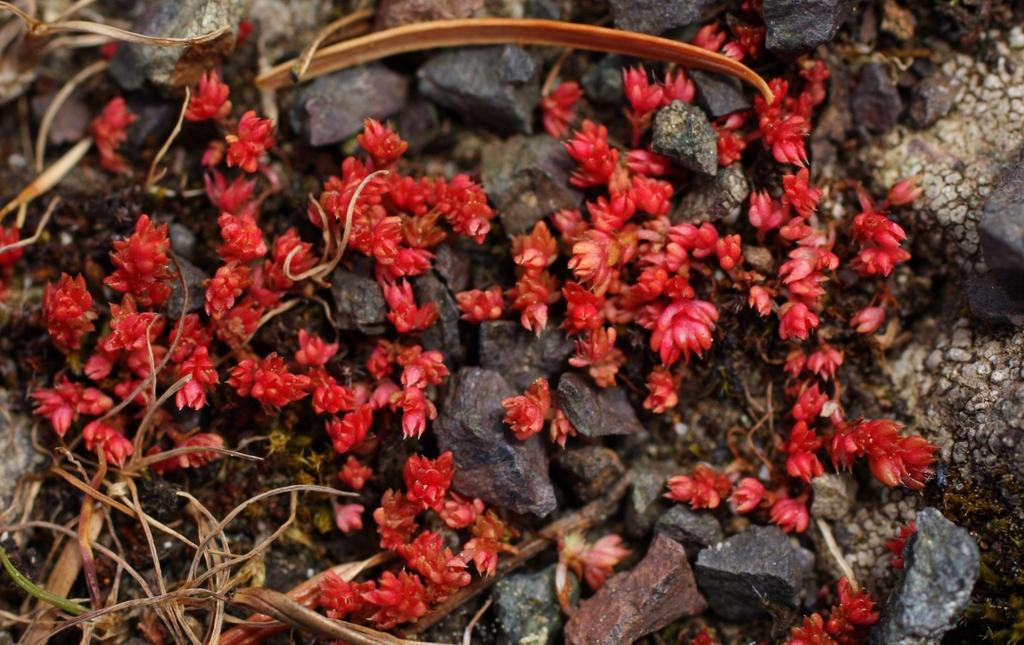What type of natural elements can be seen in the image? There are stones, flowers, and dried stems in the image. Can you describe the flowers in the image? The flowers in the image are not specified, but they are present alongside the stones and dried stems. What might be the purpose of the dried stems in the image? The dried stems in the image might be used for decoration or as a part of a floral arrangement. What type of magic is being performed with the stones in the image? There is no magic being performed in the image; it simply shows stones, flowers, and dried stems. How many heads can be seen in the image? There are no heads visible in the image, as it features only natural elements such as stones, flowers, and dried stems. 